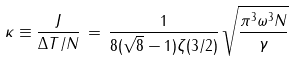<formula> <loc_0><loc_0><loc_500><loc_500>\kappa \equiv \frac { J } { \Delta T / N } \, = \, \frac { 1 } { 8 ( \sqrt { 8 } - 1 ) \zeta ( 3 / 2 ) } \, \sqrt { \frac { \pi ^ { 3 } \omega ^ { 3 } N } { \gamma } } \</formula> 